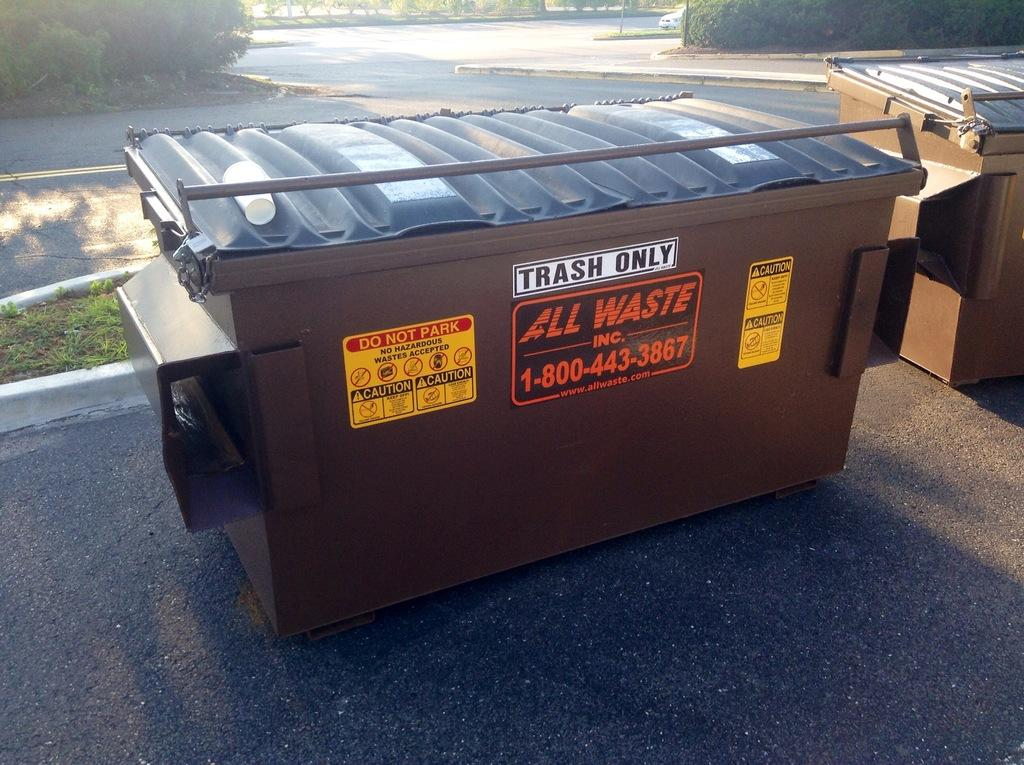<image>
Provide a brief description of the given image. A brown dumpster from All Waste has signs saying Trash Only, Do Not Park, No Hazardous Wastes, and Caution. 